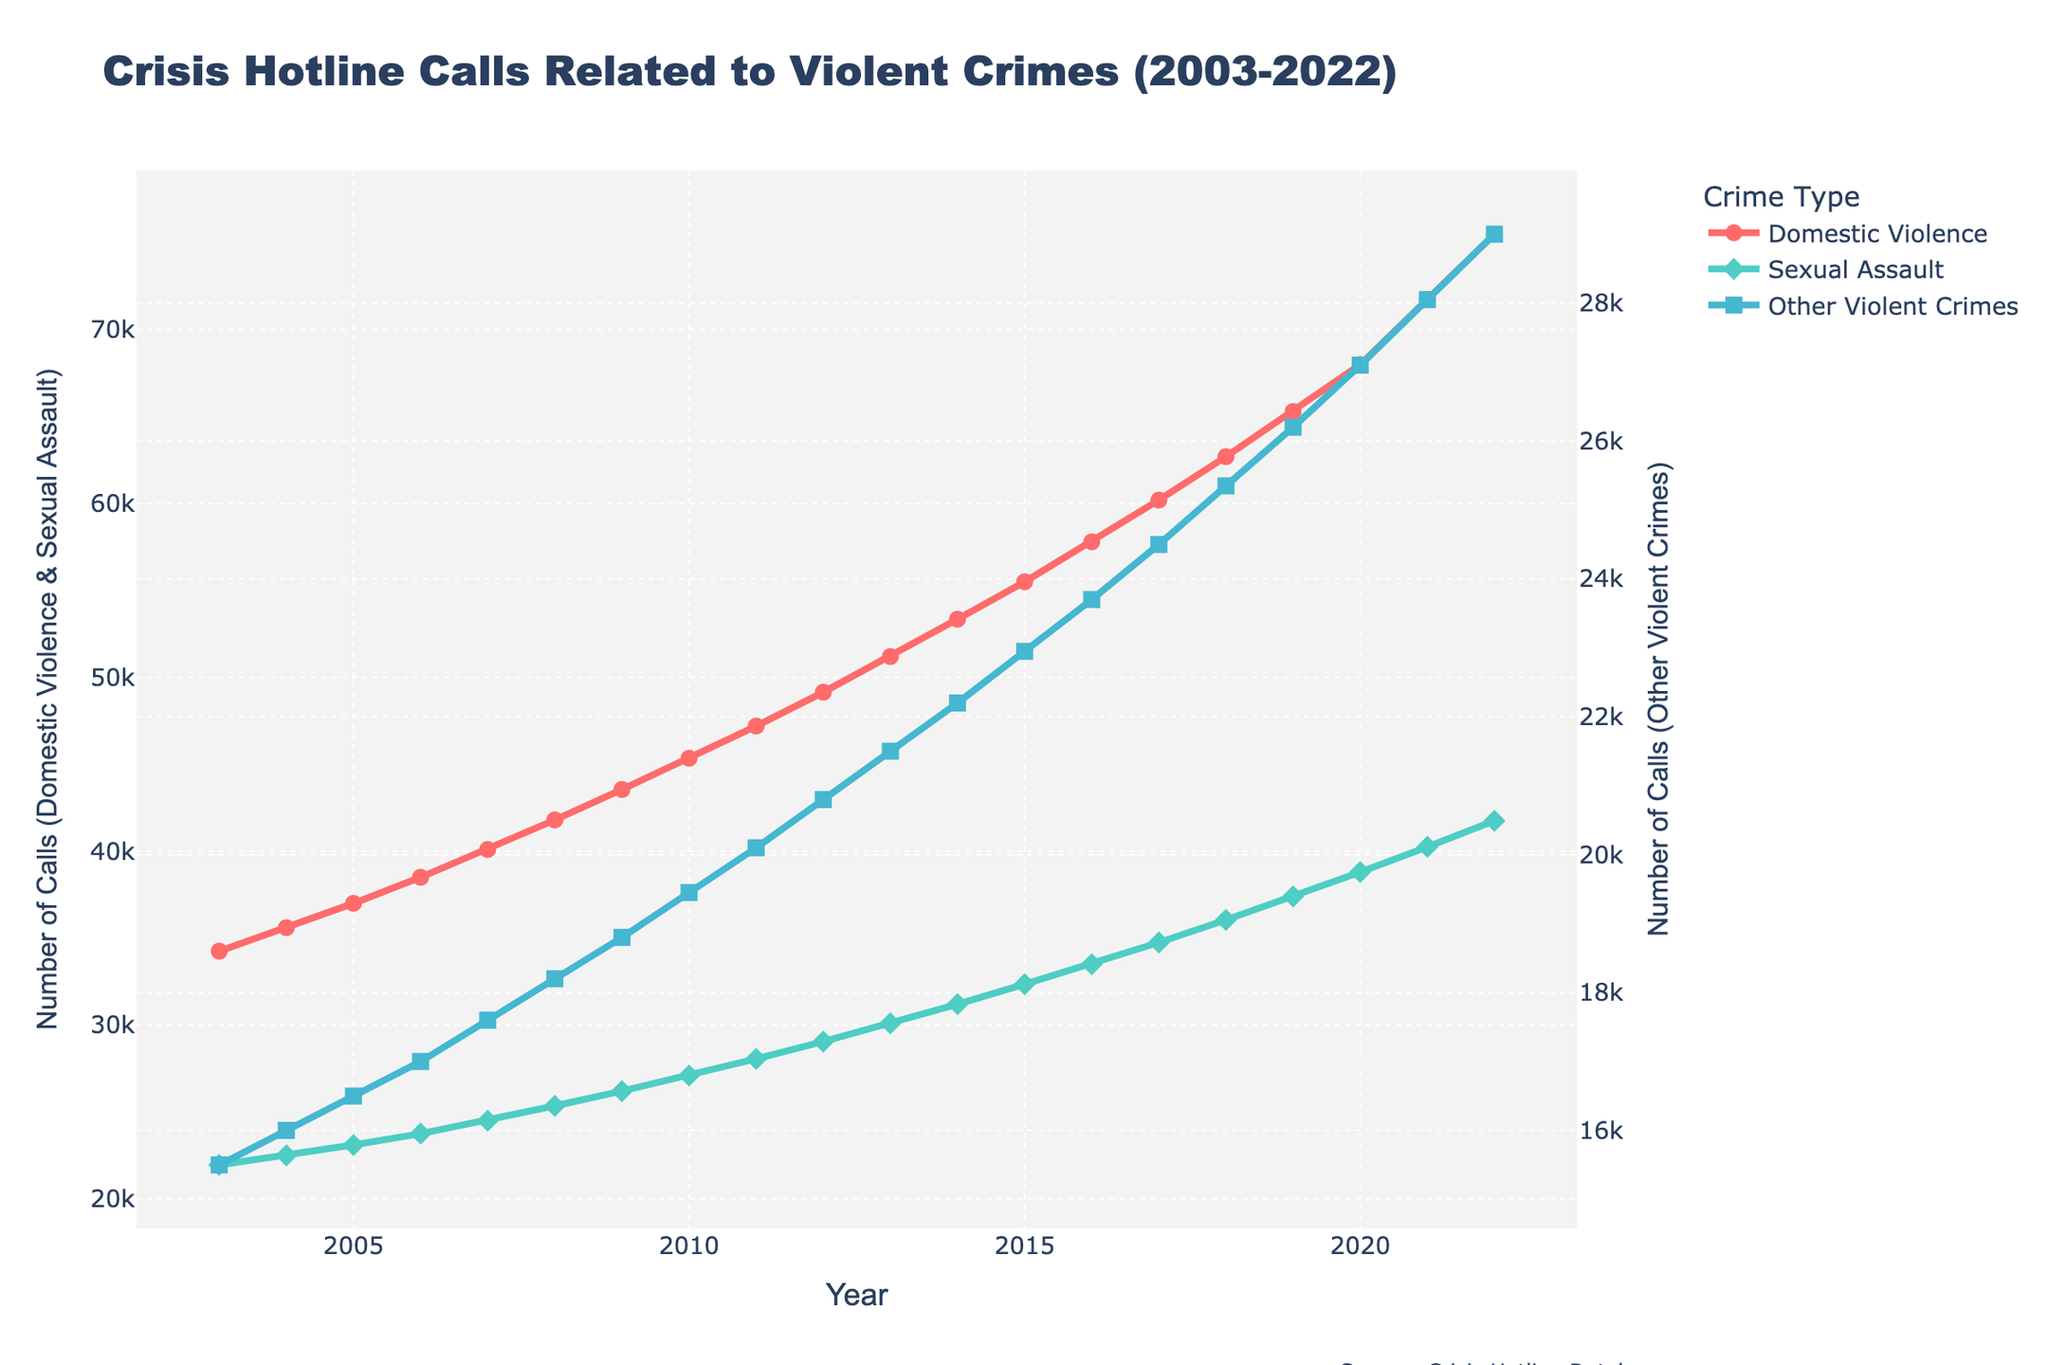what is the color of the line representing Domestic Violence calls? The plot uses color to visually differentiate between various categories. Observing the legend in the plot, the line for Domestic Violence calls is represented in a specific color.
Answer: Red What is the general trend in crisis hotline calls related to Sexual Assault from 2003 to 2022? Reviewing the plot's time series data for Sexual Assault, it shows a consistent upward trend from 2003 to 2022, meaning the number of calls increased steadily over the years.
Answer: Increasing trend What year had the highest number of calls related to Other Violent Crimes? The time series for Other Violent Crimes shows an increasing pattern. Looking at the endpoint of the series in 2022 and the call values, 2022 had the highest number of calls.
Answer: 2022 Which type of call had the steepest increase between 2010 and 2020? To determine this, examine the slope of the lines for each crime type between 2010 and 2020. The steepest slope represents the highest rate of increase. The lines for Domestic Violence and Sexual Assault both show significant increases, but calculating the steepness reveals Domestic Violence had a sharper increase.
Answer: Domestic Violence In which year did crisis hotline calls related to Domestic Violence exceed 50,000? Observing the line plot specifically for Domestic Violence, it crosses the 50,000 marks around a specific year.
Answer: 2013 Compare the number of calls for Sexual Assault and Other Violent Crimes in 2018. Which had more? Checking the values for Sexual Assault and Other Violent Crimes in 2018, it is evident from the graph that Sexual Assault had a higher number of calls in that year.
Answer: Sexual Assault What is the highest number of calls recorded for Domestic Violence over the two decades? The highest point on the Domestic Violence line plot over the 20 years represents the maximum number of calls.
Answer: 75,500 How many more calls were there for Domestic Violence than Sexual Assault in 2022? Subtract the number of Sexual Assault calls from Domestic Violence calls in 2022. Calculating this: 75,500 - 41,750 = 33,750.
Answer: 33,750 What is the average number of calls for Sexual Assault over the 20 years? First, sum the number of calls for Sexual Assault over 20 years, then divide by 20. The sum of all yearly Sexual Assault calls is 548,950. The average is 548,950 / 20 = 27,447.5
Answer: 27,447.5 Did the number of calls for Other Violent Crimes ever surpass 25,000? By examining the line representing Other Violent Crimes, it shows the numbers remain under 25,000 for all observed years.
Answer: No 